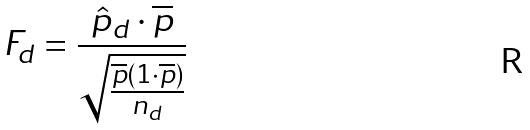Convert formula to latex. <formula><loc_0><loc_0><loc_500><loc_500>F _ { d } = \frac { \hat { p } _ { d } \cdot \overline { p } } { \sqrt { \frac { \overline { p } ( 1 \cdot \overline { p } ) } { n _ { d } } } }</formula> 